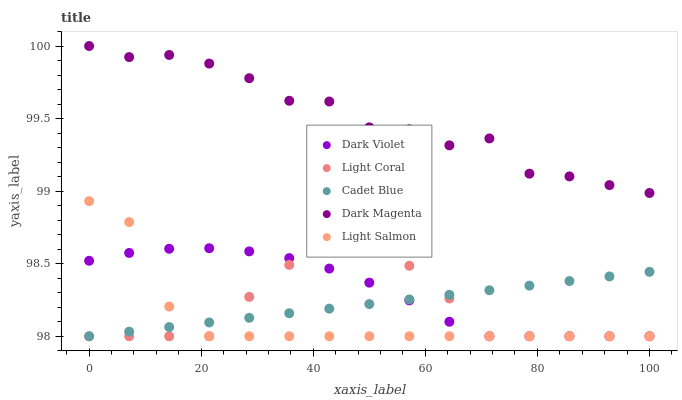Does Light Salmon have the minimum area under the curve?
Answer yes or no. Yes. Does Dark Magenta have the maximum area under the curve?
Answer yes or no. Yes. Does Cadet Blue have the minimum area under the curve?
Answer yes or no. No. Does Cadet Blue have the maximum area under the curve?
Answer yes or no. No. Is Cadet Blue the smoothest?
Answer yes or no. Yes. Is Dark Magenta the roughest?
Answer yes or no. Yes. Is Light Salmon the smoothest?
Answer yes or no. No. Is Light Salmon the roughest?
Answer yes or no. No. Does Light Coral have the lowest value?
Answer yes or no. Yes. Does Dark Magenta have the lowest value?
Answer yes or no. No. Does Dark Magenta have the highest value?
Answer yes or no. Yes. Does Light Salmon have the highest value?
Answer yes or no. No. Is Cadet Blue less than Dark Magenta?
Answer yes or no. Yes. Is Dark Magenta greater than Light Salmon?
Answer yes or no. Yes. Does Cadet Blue intersect Light Salmon?
Answer yes or no. Yes. Is Cadet Blue less than Light Salmon?
Answer yes or no. No. Is Cadet Blue greater than Light Salmon?
Answer yes or no. No. Does Cadet Blue intersect Dark Magenta?
Answer yes or no. No. 